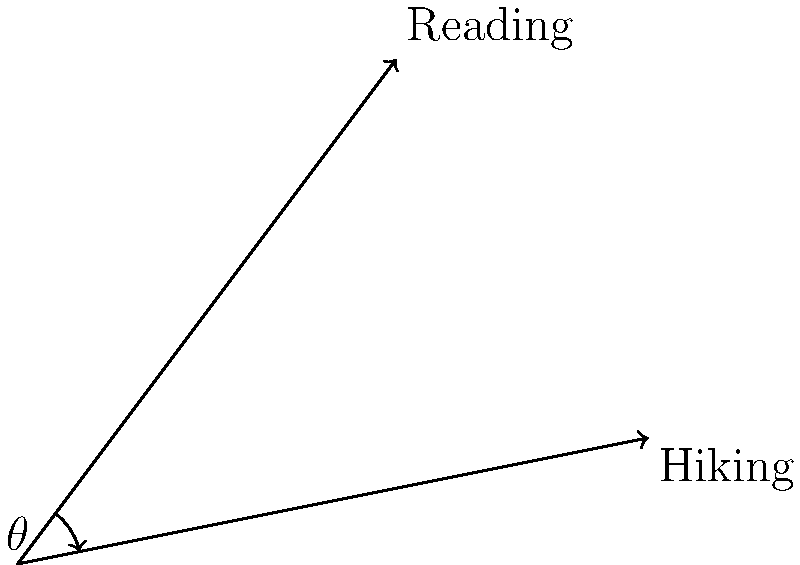Harry's two favorite activities are reading and hiking. If we represent these activities as vectors, with reading as $\vec{a} = 3\hat{i} + 4\hat{j}$ and hiking as $\vec{b} = 5\hat{i} + \hat{j}$, what is the angle $\theta$ between these two vectors? To find the angle between two vectors, we can use the dot product formula:

$$\cos \theta = \frac{\vec{a} \cdot \vec{b}}{|\vec{a}||\vec{b}|}$$

Step 1: Calculate the dot product $\vec{a} \cdot \vec{b}$
$$\vec{a} \cdot \vec{b} = (3)(5) + (4)(1) = 15 + 4 = 19$$

Step 2: Calculate the magnitudes of $\vec{a}$ and $\vec{b}$
$$|\vec{a}| = \sqrt{3^2 + 4^2} = \sqrt{9 + 16} = \sqrt{25} = 5$$
$$|\vec{b}| = \sqrt{5^2 + 1^2} = \sqrt{25 + 1} = \sqrt{26}$$

Step 3: Substitute into the formula
$$\cos \theta = \frac{19}{5\sqrt{26}}$$

Step 4: Take the inverse cosine (arccos) of both sides
$$\theta = \arccos(\frac{19}{5\sqrt{26}})$$

Step 5: Calculate the result
$$\theta \approx 0.3398 \text{ radians} \approx 19.47°$$
Answer: $19.47°$ 